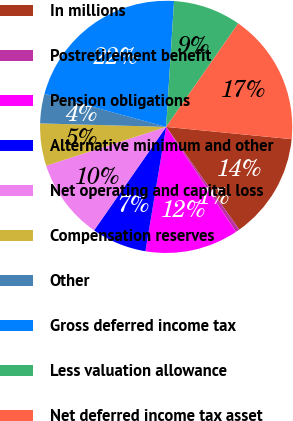Convert chart to OTSL. <chart><loc_0><loc_0><loc_500><loc_500><pie_chart><fcel>In millions<fcel>Postretirement benefit<fcel>Pension obligations<fcel>Alternative minimum and other<fcel>Net operating and capital loss<fcel>Compensation reserves<fcel>Other<fcel>Gross deferred income tax<fcel>Less valuation allowance<fcel>Net deferred income tax asset<nl><fcel>13.59%<fcel>0.52%<fcel>11.96%<fcel>7.06%<fcel>10.33%<fcel>5.42%<fcel>3.79%<fcel>21.76%<fcel>8.69%<fcel>16.86%<nl></chart> 